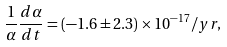Convert formula to latex. <formula><loc_0><loc_0><loc_500><loc_500>\frac { 1 } { \alpha } \frac { d \alpha } { d t } = ( - 1 . 6 \pm 2 . 3 ) \times 1 0 ^ { - 1 7 } / y r ,</formula> 